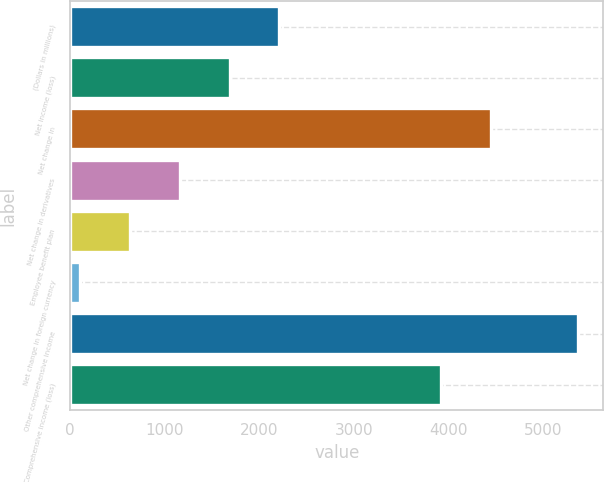Convert chart to OTSL. <chart><loc_0><loc_0><loc_500><loc_500><bar_chart><fcel>(Dollars in millions)<fcel>Net income (loss)<fcel>Net change in<fcel>Net change in derivatives<fcel>Employee benefit plan<fcel>Net change in foreign currency<fcel>Other comprehensive income<fcel>Comprehensive income (loss)<nl><fcel>2213.2<fcel>1686.9<fcel>4451.3<fcel>1160.6<fcel>634.3<fcel>108<fcel>5371<fcel>3925<nl></chart> 